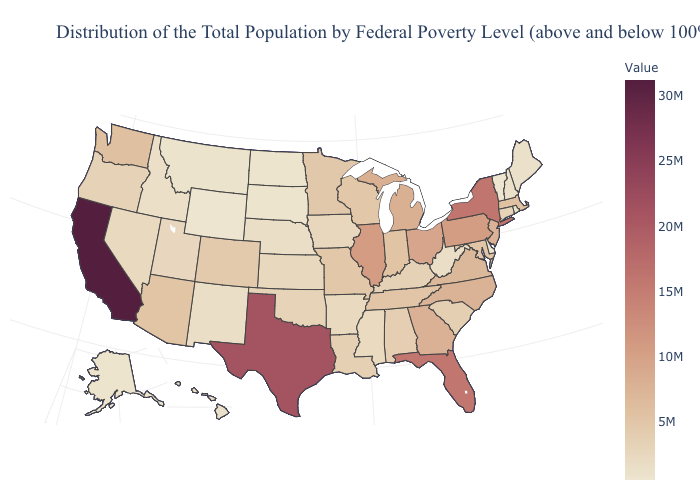Among the states that border Missouri , does Kansas have the highest value?
Keep it brief. No. 